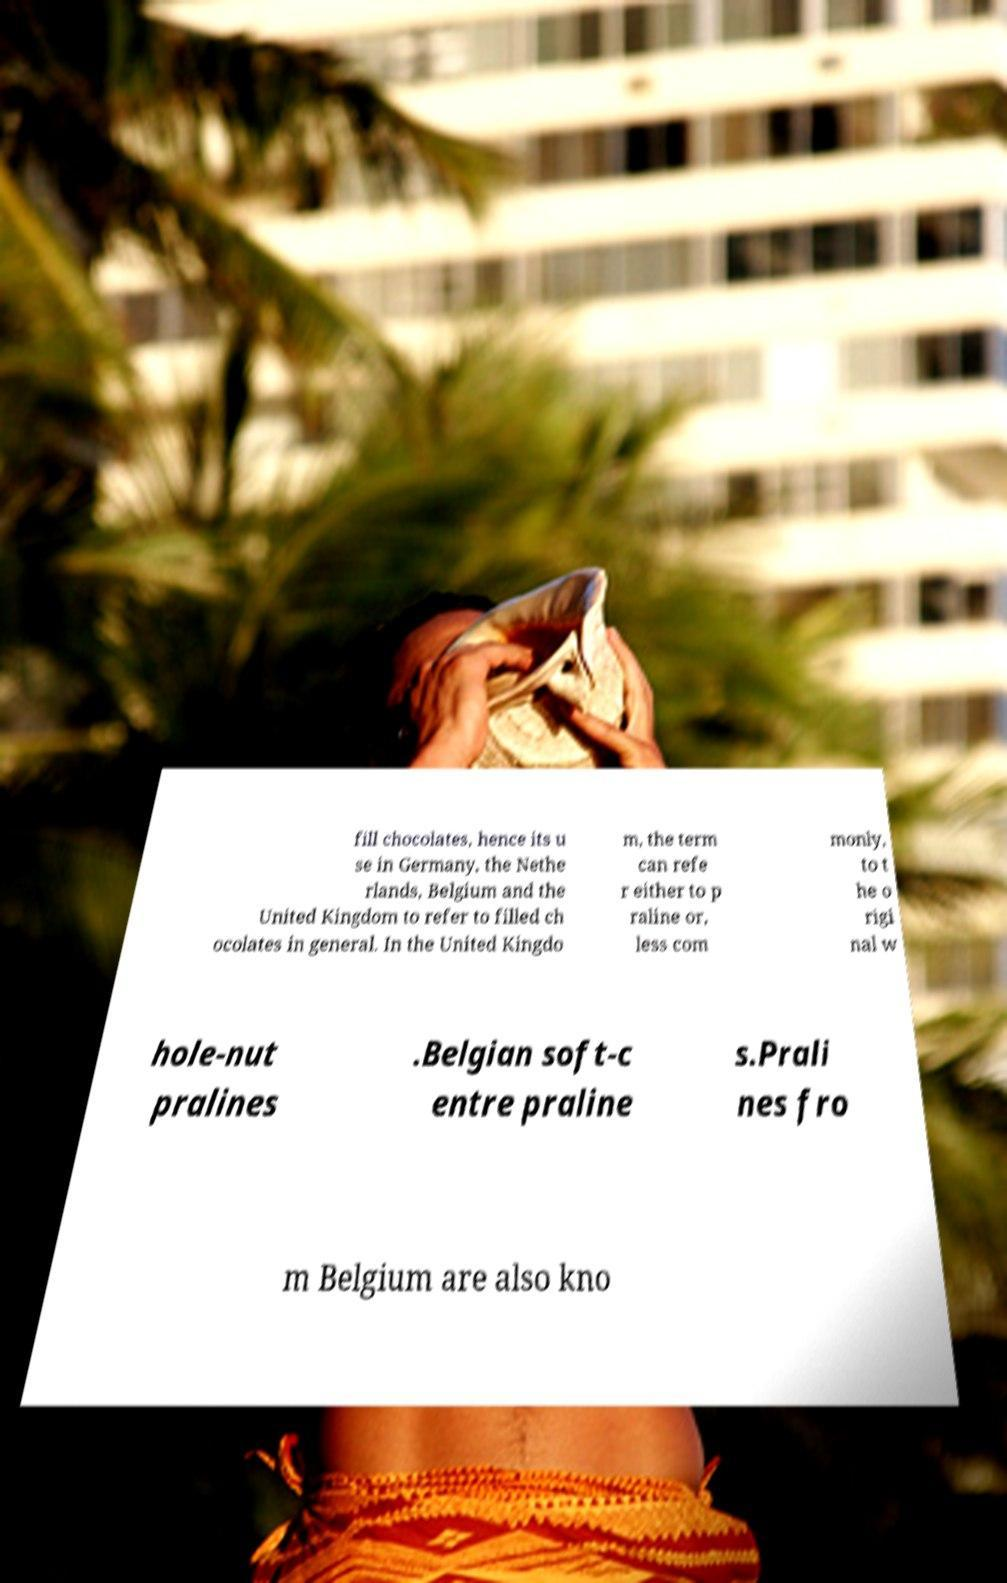Can you read and provide the text displayed in the image?This photo seems to have some interesting text. Can you extract and type it out for me? fill chocolates, hence its u se in Germany, the Nethe rlands, Belgium and the United Kingdom to refer to filled ch ocolates in general. In the United Kingdo m, the term can refe r either to p raline or, less com monly, to t he o rigi nal w hole-nut pralines .Belgian soft-c entre praline s.Prali nes fro m Belgium are also kno 